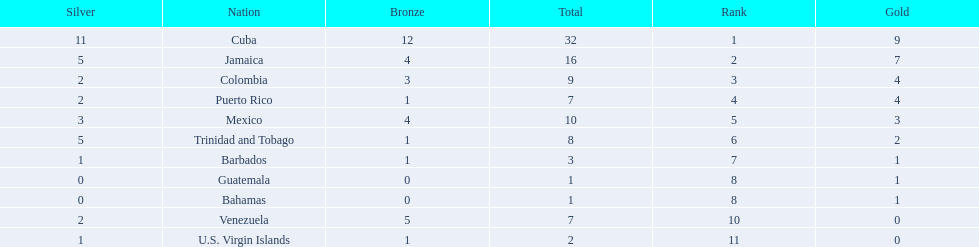Which nations played in the games? Cuba, Jamaica, Colombia, Puerto Rico, Mexico, Trinidad and Tobago, Barbados, Guatemala, Bahamas, Venezuela, U.S. Virgin Islands. How many silver medals did they win? 11, 5, 2, 2, 3, 5, 1, 0, 0, 2, 1. Which team won the most silver? Cuba. 